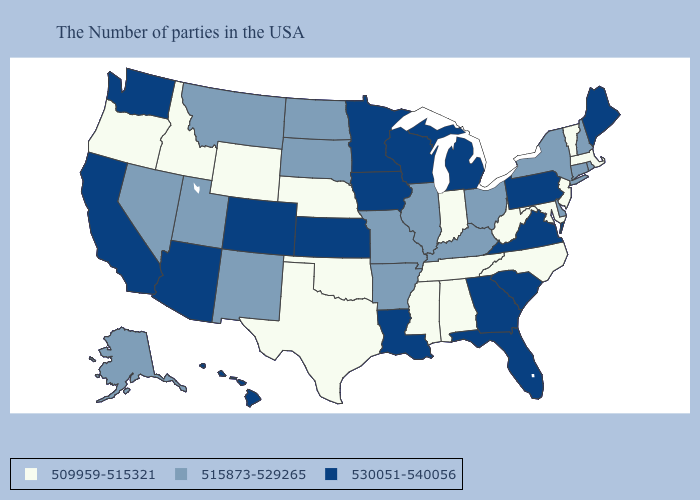Name the states that have a value in the range 509959-515321?
Concise answer only. Massachusetts, Vermont, New Jersey, Maryland, North Carolina, West Virginia, Indiana, Alabama, Tennessee, Mississippi, Nebraska, Oklahoma, Texas, Wyoming, Idaho, Oregon. Does Idaho have a lower value than Mississippi?
Quick response, please. No. Which states have the highest value in the USA?
Short answer required. Maine, Pennsylvania, Virginia, South Carolina, Florida, Georgia, Michigan, Wisconsin, Louisiana, Minnesota, Iowa, Kansas, Colorado, Arizona, California, Washington, Hawaii. What is the highest value in the MidWest ?
Write a very short answer. 530051-540056. Name the states that have a value in the range 515873-529265?
Short answer required. Rhode Island, New Hampshire, Connecticut, New York, Delaware, Ohio, Kentucky, Illinois, Missouri, Arkansas, South Dakota, North Dakota, New Mexico, Utah, Montana, Nevada, Alaska. Name the states that have a value in the range 530051-540056?
Quick response, please. Maine, Pennsylvania, Virginia, South Carolina, Florida, Georgia, Michigan, Wisconsin, Louisiana, Minnesota, Iowa, Kansas, Colorado, Arizona, California, Washington, Hawaii. What is the value of Colorado?
Answer briefly. 530051-540056. What is the value of Hawaii?
Answer briefly. 530051-540056. Does Kentucky have a higher value than Nebraska?
Short answer required. Yes. What is the highest value in the Northeast ?
Quick response, please. 530051-540056. What is the value of Michigan?
Short answer required. 530051-540056. What is the lowest value in the USA?
Give a very brief answer. 509959-515321. What is the highest value in states that border New Mexico?
Write a very short answer. 530051-540056. Which states have the highest value in the USA?
Concise answer only. Maine, Pennsylvania, Virginia, South Carolina, Florida, Georgia, Michigan, Wisconsin, Louisiana, Minnesota, Iowa, Kansas, Colorado, Arizona, California, Washington, Hawaii. What is the lowest value in the MidWest?
Be succinct. 509959-515321. 